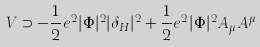Convert formula to latex. <formula><loc_0><loc_0><loc_500><loc_500>V \supset - \frac { 1 } { 2 } e ^ { 2 } | \Phi | ^ { 2 } | \delta _ { H } | ^ { 2 } + \frac { 1 } { 2 } e ^ { 2 } | \Phi | ^ { 2 } A _ { \mu } A ^ { \mu }</formula> 